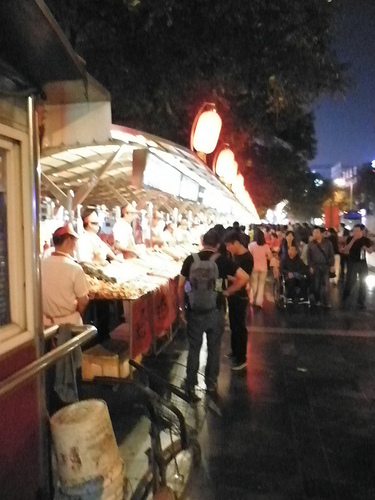<image>
Is the light above the man? Yes. The light is positioned above the man in the vertical space, higher up in the scene. 